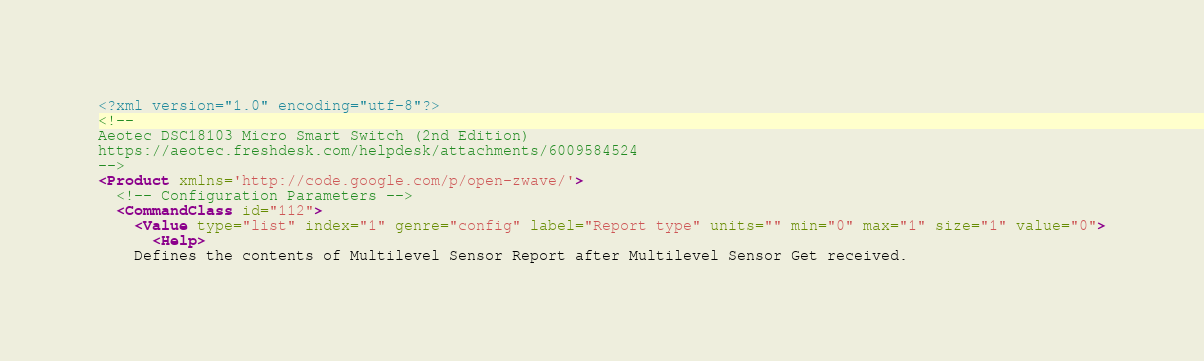<code> <loc_0><loc_0><loc_500><loc_500><_XML_><?xml version="1.0" encoding="utf-8"?>
<!-- 
Aeotec DSC18103 Micro Smart Switch (2nd Edition)
https://aeotec.freshdesk.com/helpdesk/attachments/6009584524
-->
<Product xmlns='http://code.google.com/p/open-zwave/'>
  <!-- Configuration Parameters -->
  <CommandClass id="112">
    <Value type="list" index="1" genre="config" label="Report type" units="" min="0" max="1" size="1" value="0">
      <Help>
	Defines the contents of Multilevel Sensor Report after Multilevel Sensor Get received.</code> 